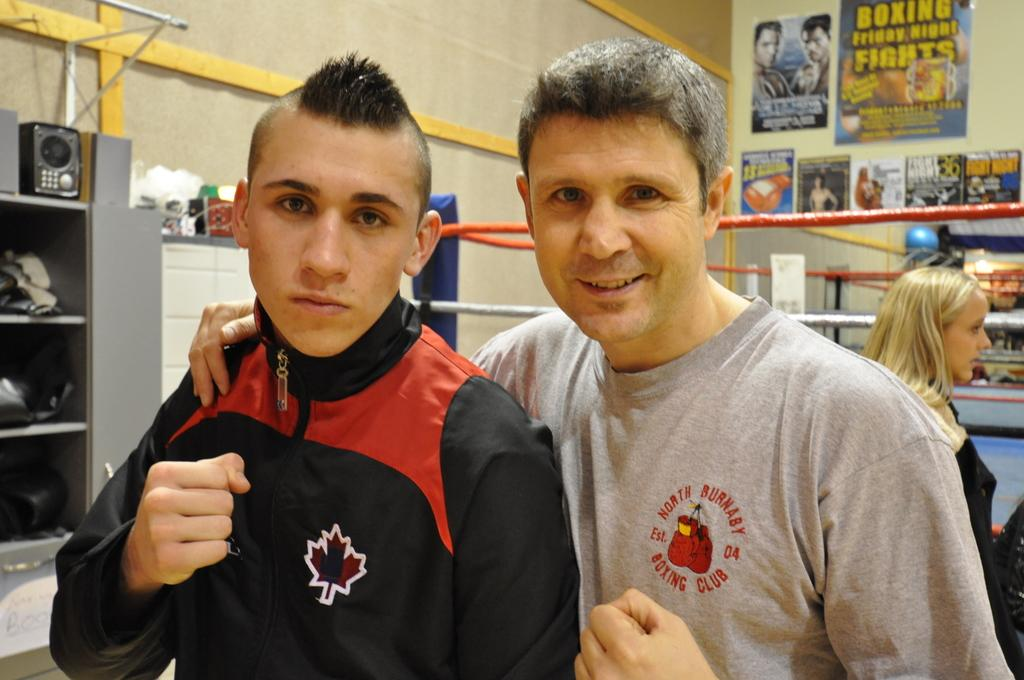<image>
Provide a brief description of the given image. Two people are standing next to each other and one has "North Burnaby" on his shirt. 